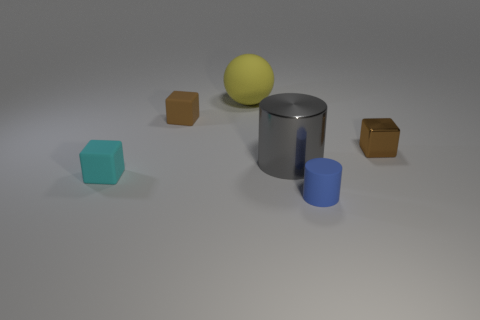Is there another tiny thing that has the same color as the tiny shiny object?
Keep it short and to the point. Yes. The tiny object that is the same color as the metal cube is what shape?
Your answer should be very brief. Cube. Do the matte block to the right of the small cyan thing and the tiny metal object have the same color?
Offer a very short reply. Yes. Is the size of the shiny cylinder the same as the cyan rubber object?
Keep it short and to the point. No. There is another thing that is the same shape as the gray shiny object; what material is it?
Provide a short and direct response. Rubber. Is there any other thing that has the same material as the large gray object?
Give a very brief answer. Yes. How many purple things are small shiny objects or large objects?
Provide a succinct answer. 0. What is the brown block to the right of the large yellow rubber sphere made of?
Your answer should be compact. Metal. Is the number of large spheres greater than the number of red spheres?
Offer a very short reply. Yes. Do the tiny brown object to the left of the big gray metallic thing and the blue thing have the same shape?
Offer a terse response. No. 